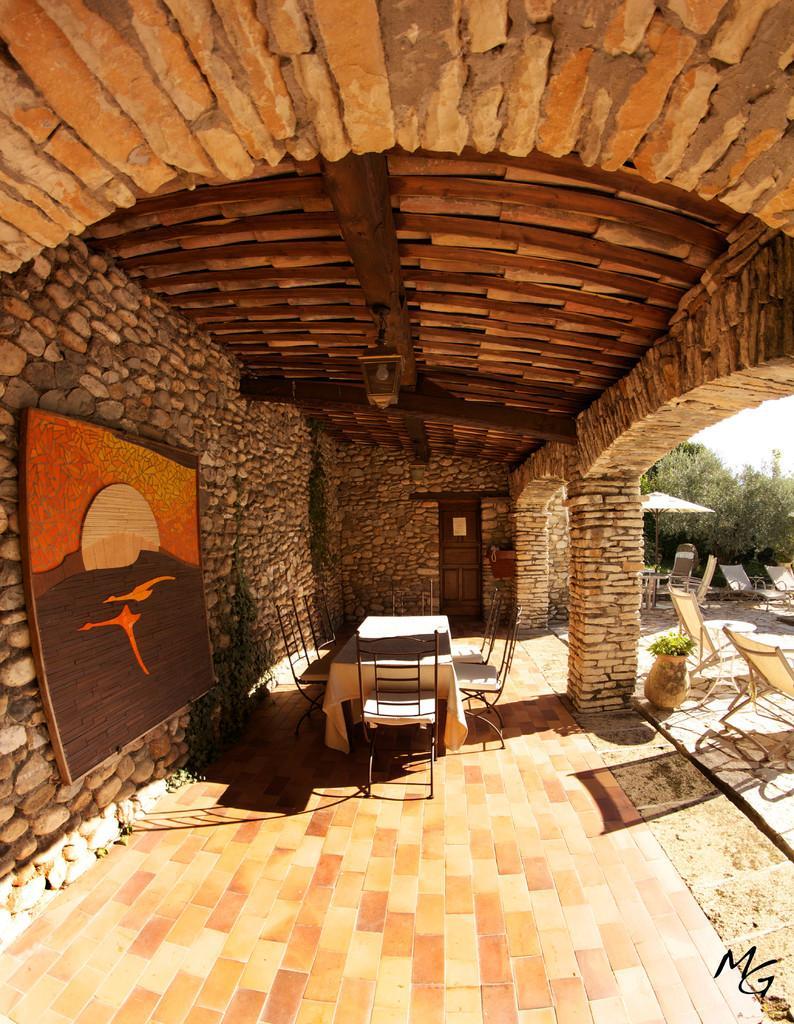Describe this image in one or two sentences. In this image we can see a dining table with chairs. Near to that there are brick walls and pillar. On the wall there is a painting. On the right side there are chairs, pot with plants and trees. In the right bottom corner something is written. 